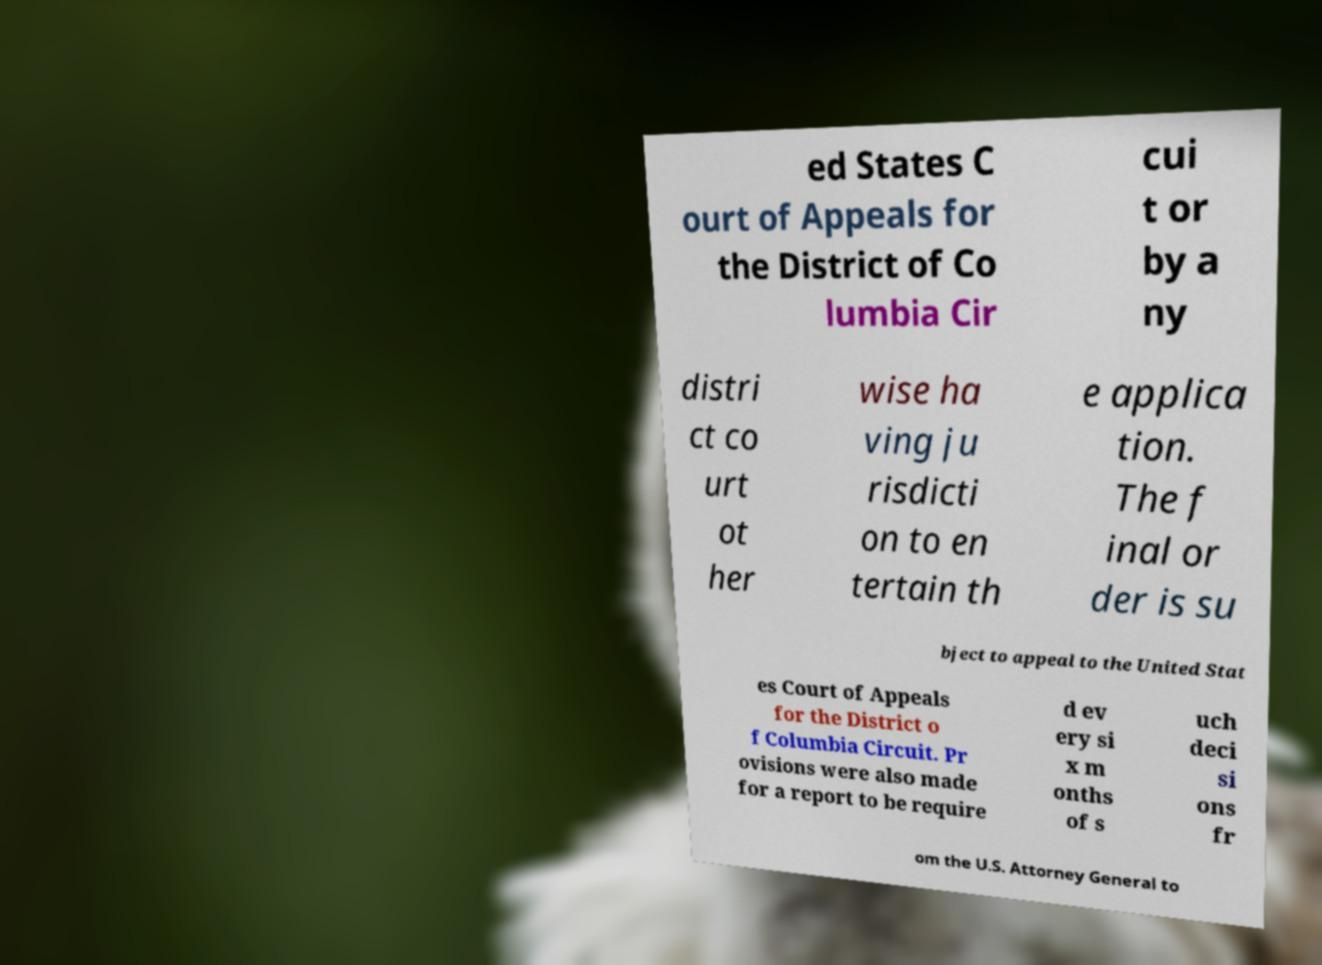Could you extract and type out the text from this image? ed States C ourt of Appeals for the District of Co lumbia Cir cui t or by a ny distri ct co urt ot her wise ha ving ju risdicti on to en tertain th e applica tion. The f inal or der is su bject to appeal to the United Stat es Court of Appeals for the District o f Columbia Circuit. Pr ovisions were also made for a report to be require d ev ery si x m onths of s uch deci si ons fr om the U.S. Attorney General to 